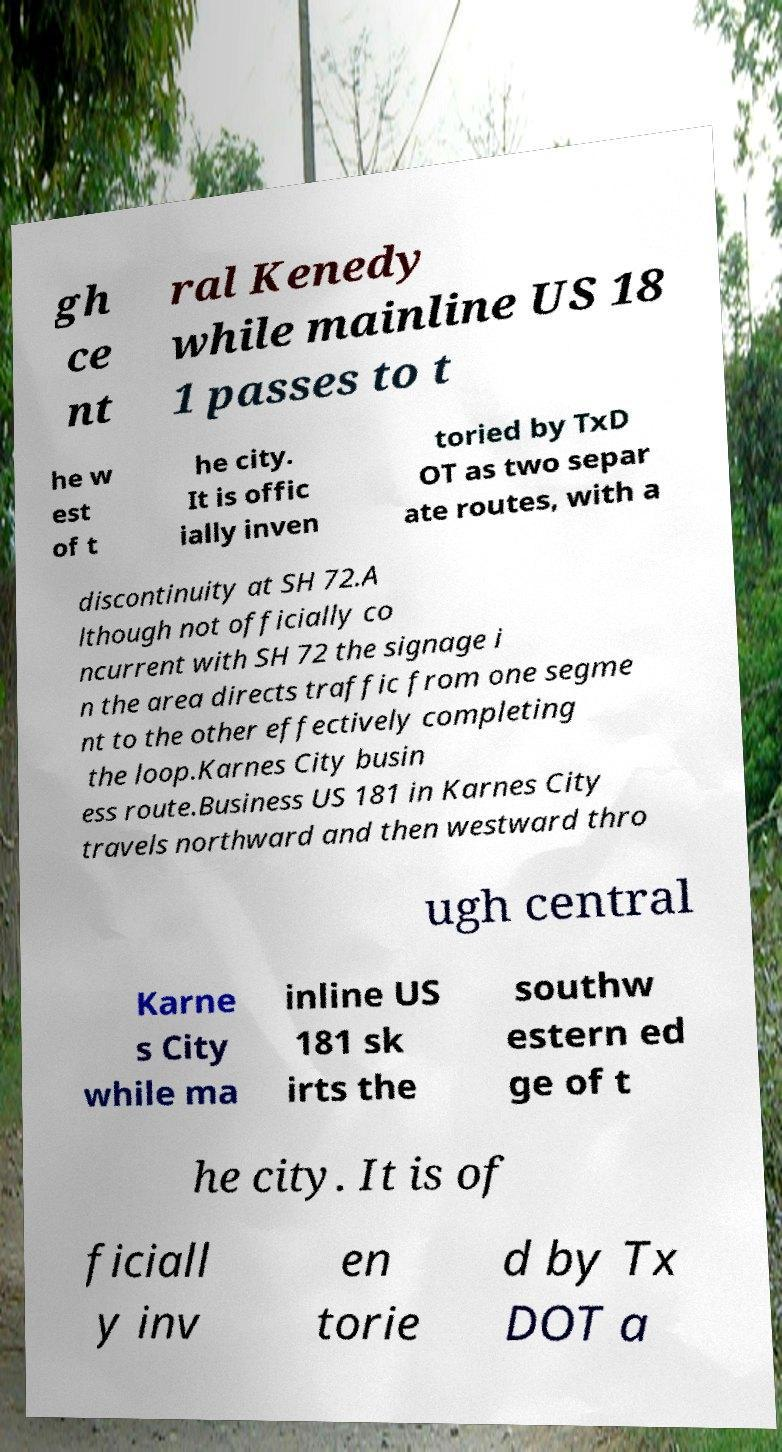Please identify and transcribe the text found in this image. gh ce nt ral Kenedy while mainline US 18 1 passes to t he w est of t he city. It is offic ially inven toried by TxD OT as two separ ate routes, with a discontinuity at SH 72.A lthough not officially co ncurrent with SH 72 the signage i n the area directs traffic from one segme nt to the other effectively completing the loop.Karnes City busin ess route.Business US 181 in Karnes City travels northward and then westward thro ugh central Karne s City while ma inline US 181 sk irts the southw estern ed ge of t he city. It is of ficiall y inv en torie d by Tx DOT a 